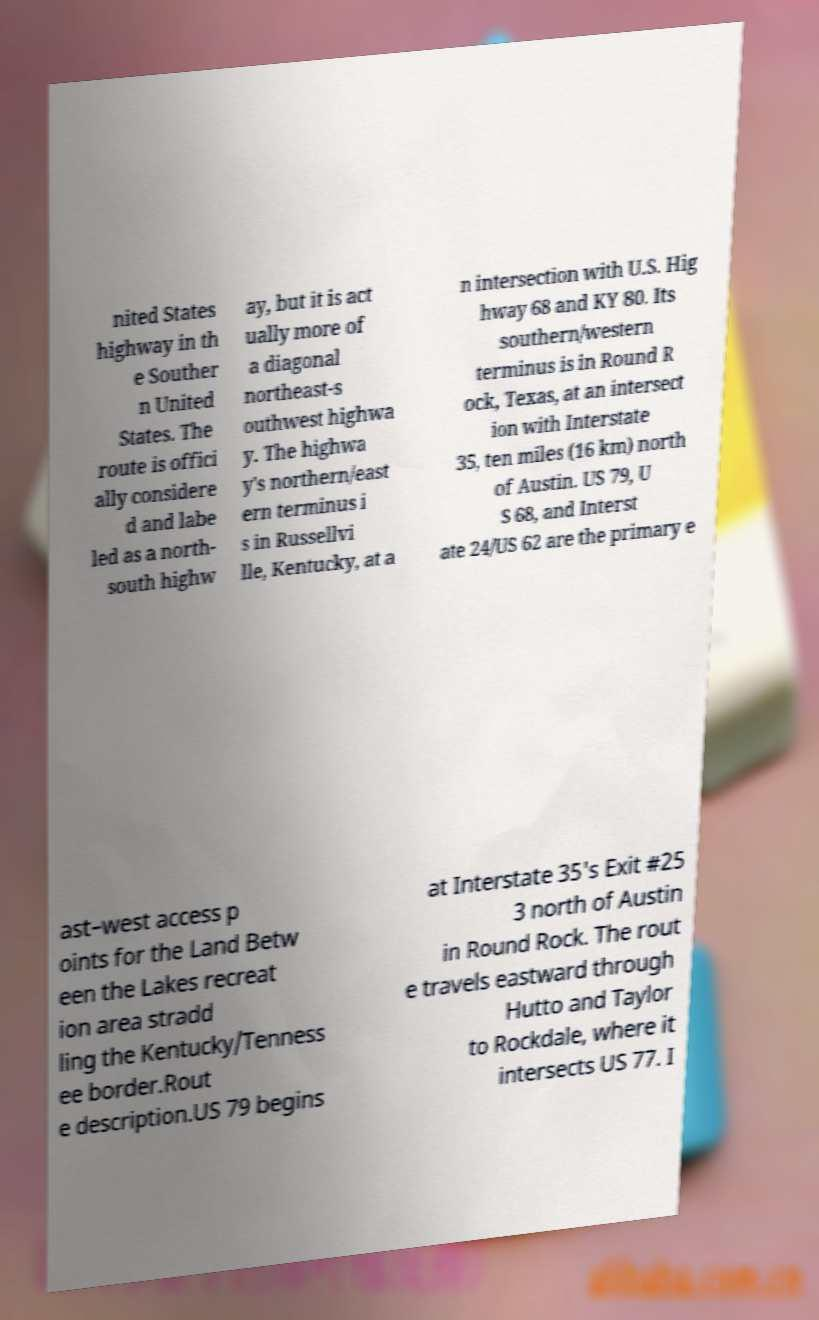Can you read and provide the text displayed in the image?This photo seems to have some interesting text. Can you extract and type it out for me? nited States highway in th e Souther n United States. The route is offici ally considere d and labe led as a north- south highw ay, but it is act ually more of a diagonal northeast-s outhwest highwa y. The highwa y's northern/east ern terminus i s in Russellvi lle, Kentucky, at a n intersection with U.S. Hig hway 68 and KY 80. Its southern/western terminus is in Round R ock, Texas, at an intersect ion with Interstate 35, ten miles (16 km) north of Austin. US 79, U S 68, and Interst ate 24/US 62 are the primary e ast–west access p oints for the Land Betw een the Lakes recreat ion area stradd ling the Kentucky/Tenness ee border.Rout e description.US 79 begins at Interstate 35's Exit #25 3 north of Austin in Round Rock. The rout e travels eastward through Hutto and Taylor to Rockdale, where it intersects US 77. I 